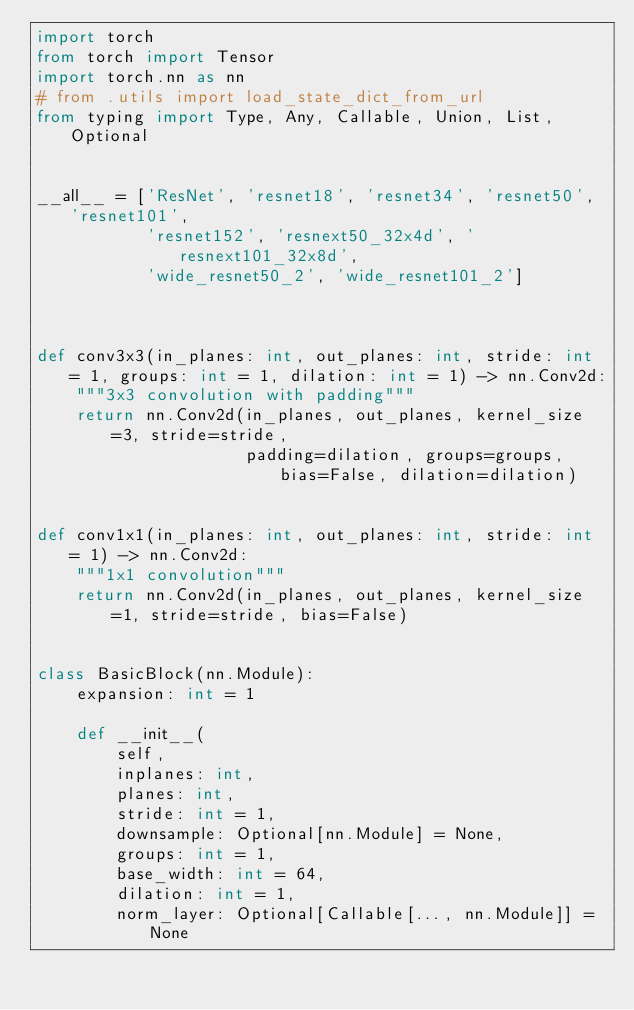<code> <loc_0><loc_0><loc_500><loc_500><_Python_>import torch
from torch import Tensor
import torch.nn as nn
# from .utils import load_state_dict_from_url
from typing import Type, Any, Callable, Union, List, Optional


__all__ = ['ResNet', 'resnet18', 'resnet34', 'resnet50', 'resnet101',
           'resnet152', 'resnext50_32x4d', 'resnext101_32x8d',
           'wide_resnet50_2', 'wide_resnet101_2']



def conv3x3(in_planes: int, out_planes: int, stride: int = 1, groups: int = 1, dilation: int = 1) -> nn.Conv2d:
    """3x3 convolution with padding"""
    return nn.Conv2d(in_planes, out_planes, kernel_size=3, stride=stride,
                     padding=dilation, groups=groups, bias=False, dilation=dilation)


def conv1x1(in_planes: int, out_planes: int, stride: int = 1) -> nn.Conv2d:
    """1x1 convolution"""
    return nn.Conv2d(in_planes, out_planes, kernel_size=1, stride=stride, bias=False)


class BasicBlock(nn.Module):
    expansion: int = 1

    def __init__(
        self,
        inplanes: int,
        planes: int,
        stride: int = 1,
        downsample: Optional[nn.Module] = None,
        groups: int = 1,
        base_width: int = 64,
        dilation: int = 1,
        norm_layer: Optional[Callable[..., nn.Module]] = None</code> 